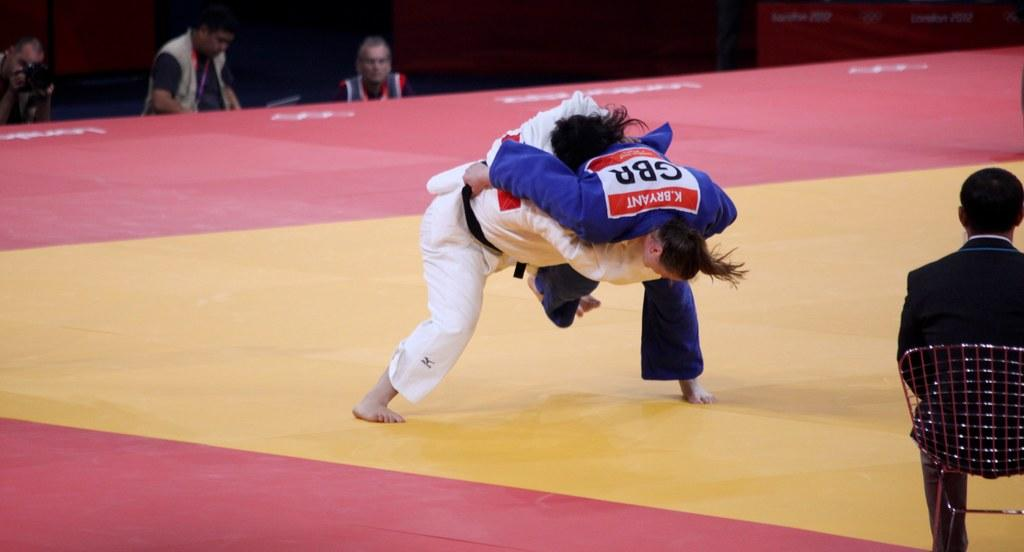<image>
Render a clear and concise summary of the photo. K Byrant wrestles a person wearing white clothing 